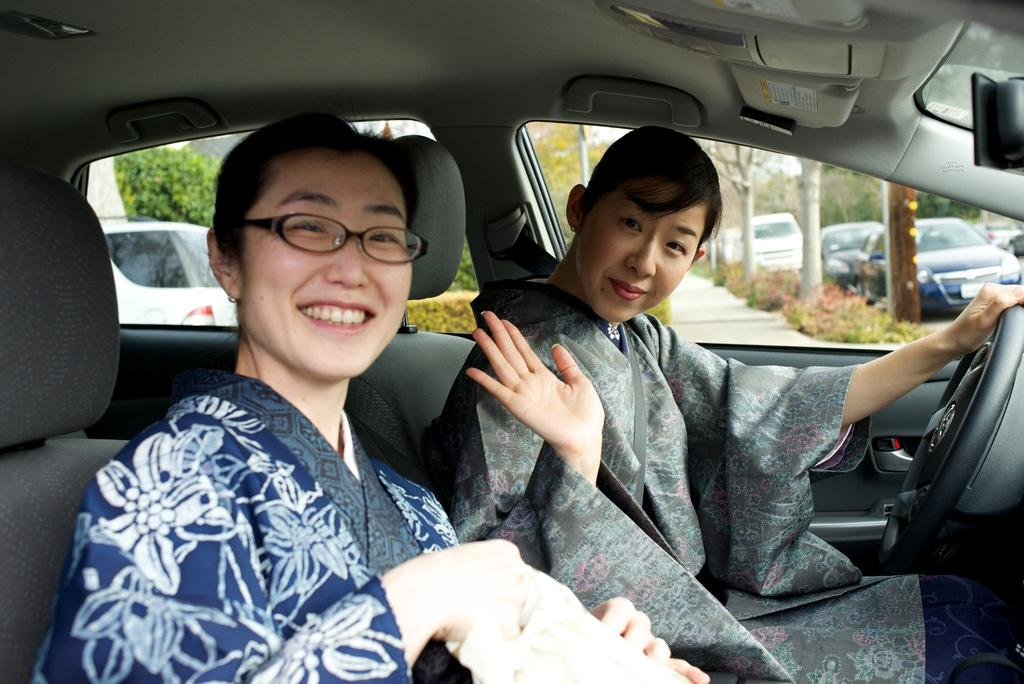How many women are present in the image? There are two women in the image. What is the facial expression of the women in the image? The women are smiling in the image. What mode of transportation are the women using in the image? The women are traveling in a car. What else can be seen in the image besides the women and the car? There are parked cars visible in the image. What type of bridge can be seen in the image? There is no bridge present in the image. What religious symbols can be seen in the image? There are no religious symbols present in the image. 